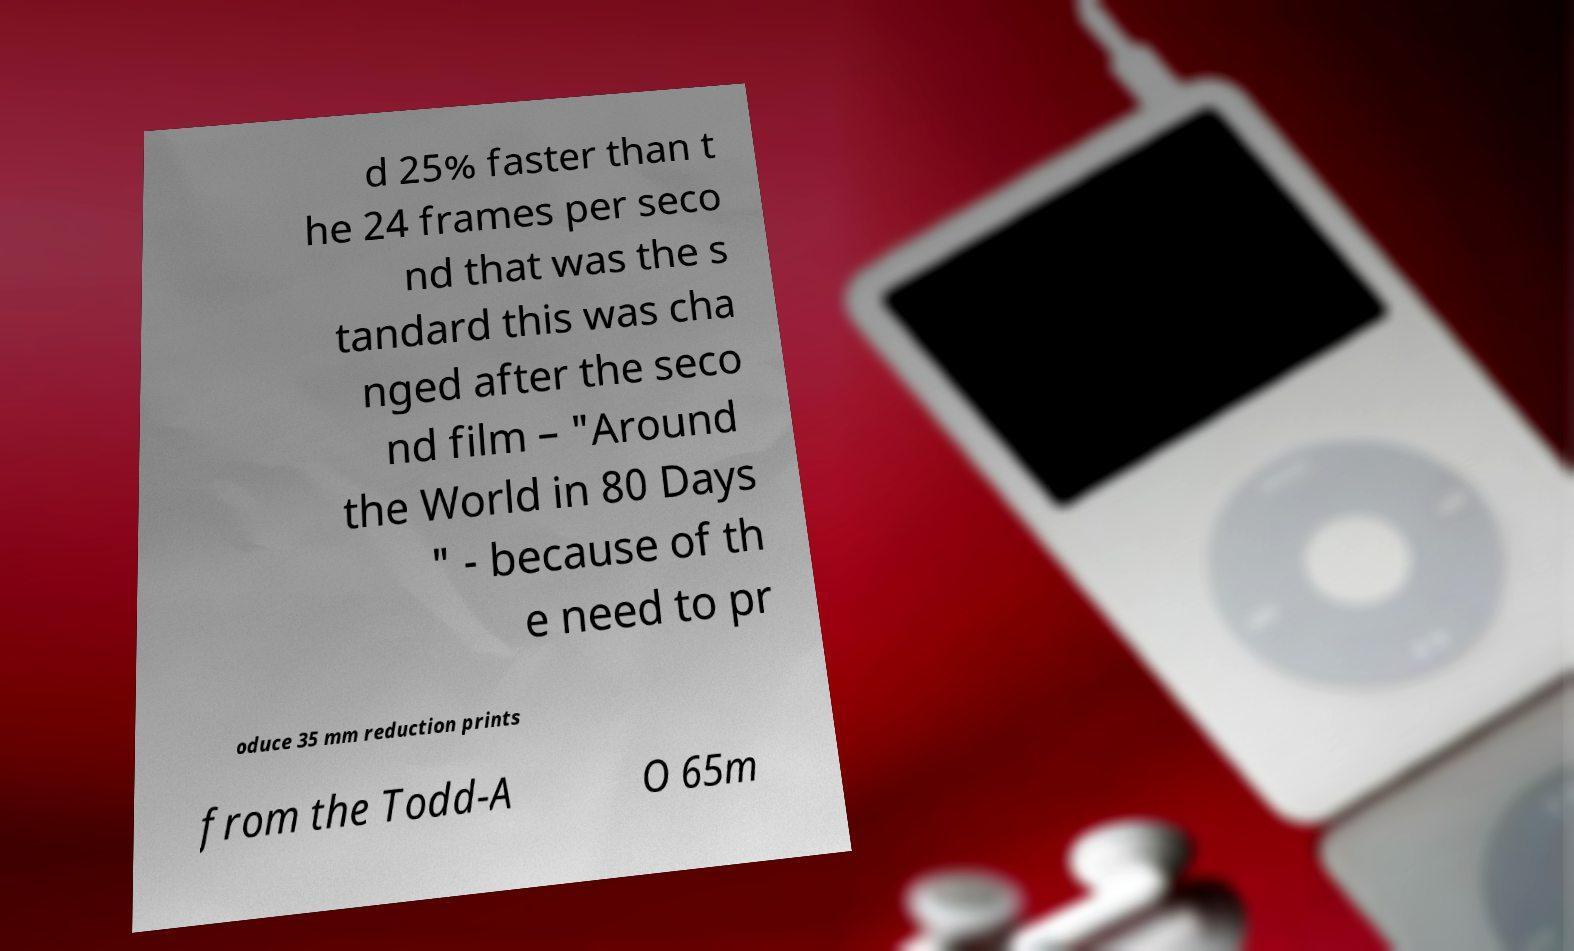Could you extract and type out the text from this image? d 25% faster than t he 24 frames per seco nd that was the s tandard this was cha nged after the seco nd film – "Around the World in 80 Days " - because of th e need to pr oduce 35 mm reduction prints from the Todd-A O 65m 